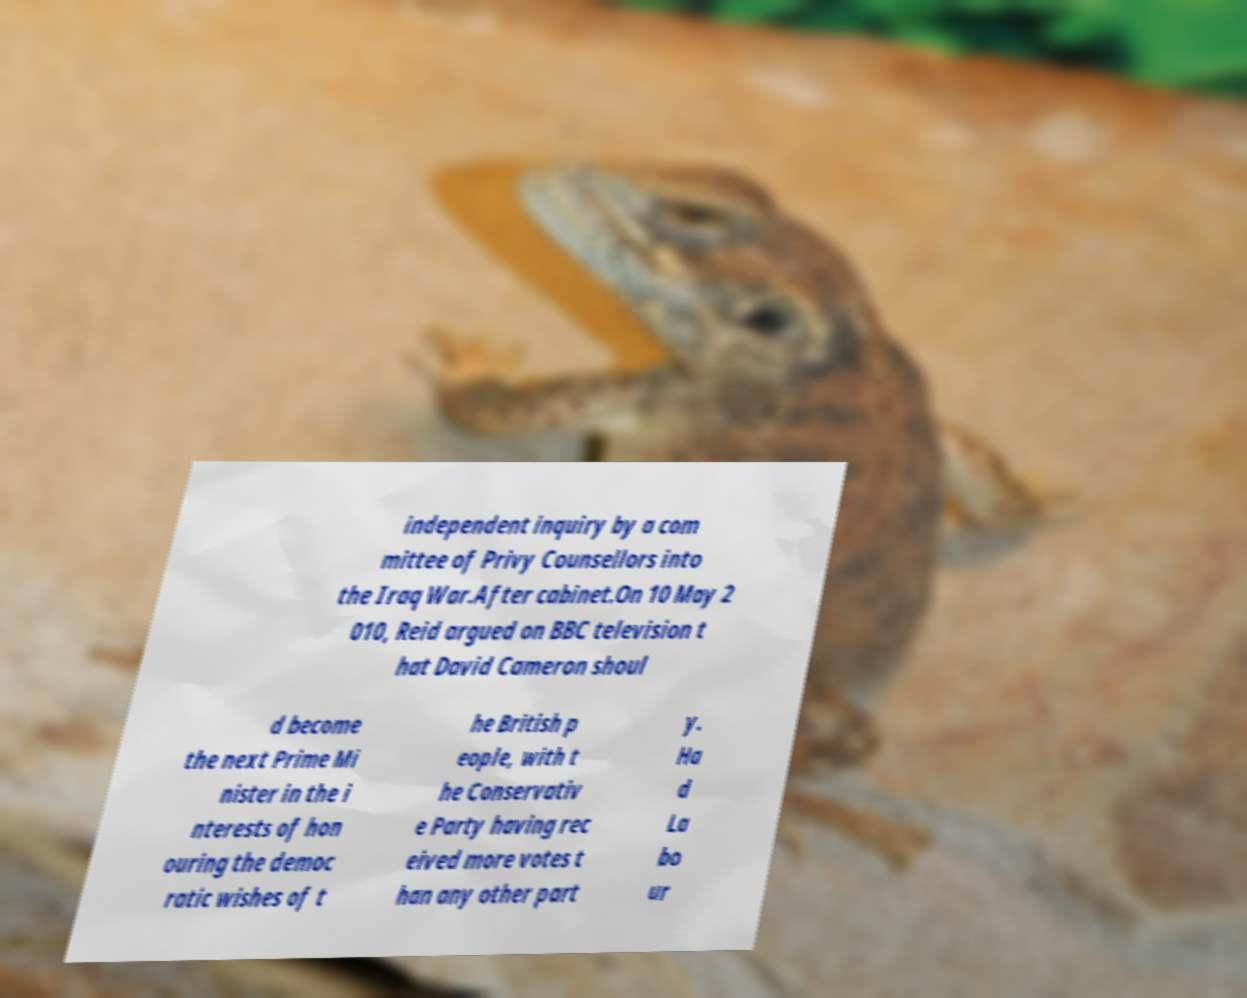There's text embedded in this image that I need extracted. Can you transcribe it verbatim? independent inquiry by a com mittee of Privy Counsellors into the Iraq War.After cabinet.On 10 May 2 010, Reid argued on BBC television t hat David Cameron shoul d become the next Prime Mi nister in the i nterests of hon ouring the democ ratic wishes of t he British p eople, with t he Conservativ e Party having rec eived more votes t han any other part y. Ha d La bo ur 